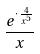<formula> <loc_0><loc_0><loc_500><loc_500>\frac { e ^ { \cdot \frac { 4 } { x ^ { 5 } } } } { x }</formula> 